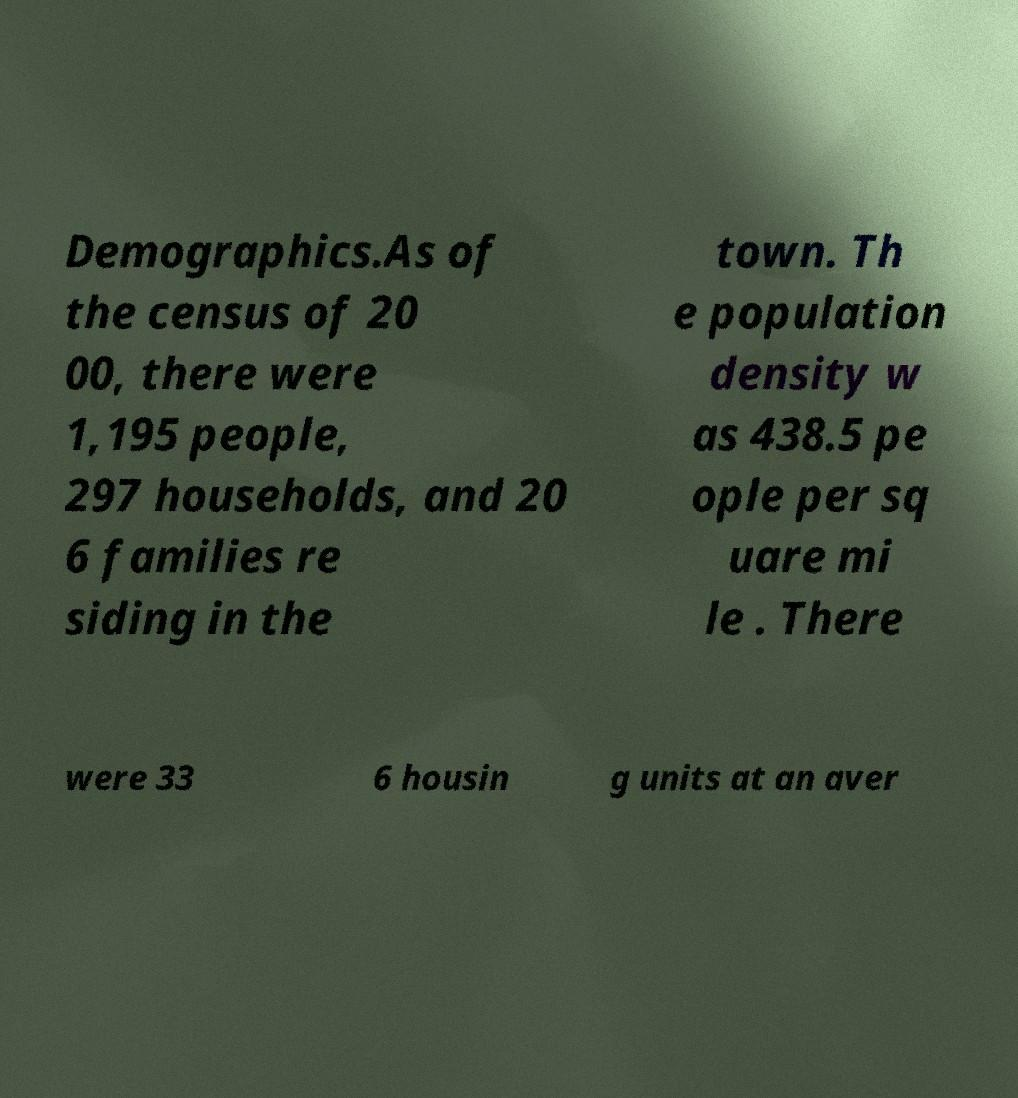Can you read and provide the text displayed in the image?This photo seems to have some interesting text. Can you extract and type it out for me? Demographics.As of the census of 20 00, there were 1,195 people, 297 households, and 20 6 families re siding in the town. Th e population density w as 438.5 pe ople per sq uare mi le . There were 33 6 housin g units at an aver 